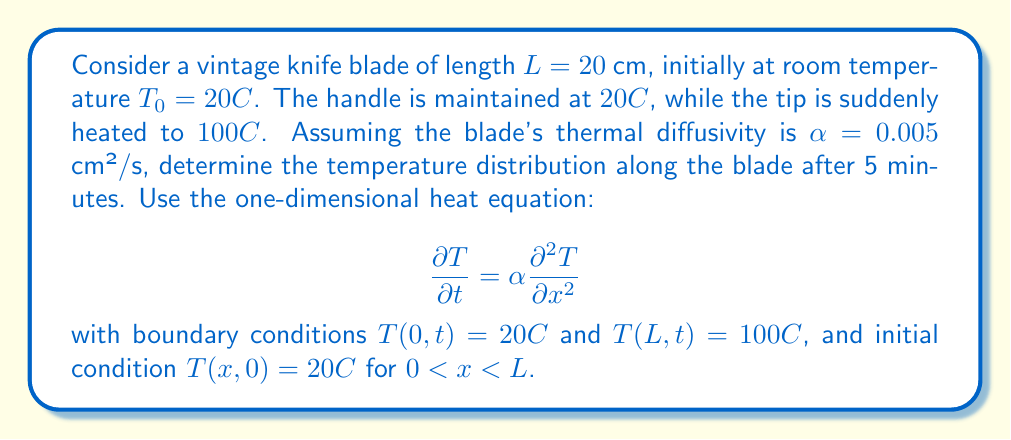Solve this math problem. To solve this problem, we'll use the separation of variables method for the heat equation.

1) First, we seek a solution of the form $T(x,t) = X(x)Y(t)$.

2) Substituting this into the heat equation:

   $$XY' = \alpha X''Y$$

3) Dividing both sides by $\alpha XY$:

   $$\frac{Y'}{αY} = \frac{X''}{X} = -λ^2$$

   where $-λ^2$ is a separation constant.

4) This gives us two ordinary differential equations:
   
   $$Y' + αλ^2Y = 0$$
   $$X'' + λ^2X = 0$$

5) The general solutions are:
   
   $$Y(t) = Ae^{-αλ^2t}$$
   $$X(x) = B\sin(λx) + C\cos(λx)$$

6) Applying the boundary conditions:
   
   $T(0,t) = 20°C$ implies $C = 20$
   $T(L,t) = 100°C$ implies $B\sin(λL) + 20 = 100$

7) The eigenvalues $λ_n$ are given by:
   
   $$λ_n = \frac{nπ}{L}, n = 1,2,3,...$$

8) The complete solution is:

   $$T(x,t) = 20 + 80\sum_{n=1}^{\infty} \frac{\sin(nπx/L)}{nπ}e^{-α(nπ/L)^2t}$$

9) For $t = 5$ minutes = 300 seconds, $L = 20$ cm, and $α = 0.005$ cm²/s:

   $$T(x,300) = 20 + 80\sum_{n=1}^{\infty} \frac{\sin(nπx/20)}{nπ}e^{-0.005(nπ/20)^2300}$$

10) This series converges rapidly. We can approximate the solution by taking the first few terms.
Answer: The temperature distribution along the blade after 5 minutes is approximated by:

$$T(x,300) \approx 20 + 80\sum_{n=1}^{5} \frac{\sin(nπx/20)}{nπ}e^{-0.005(nπ/20)^2300}$$

where $x$ is the distance from the handle in cm. This gives a smooth curve from 20°C at the handle to 100°C at the tip. 